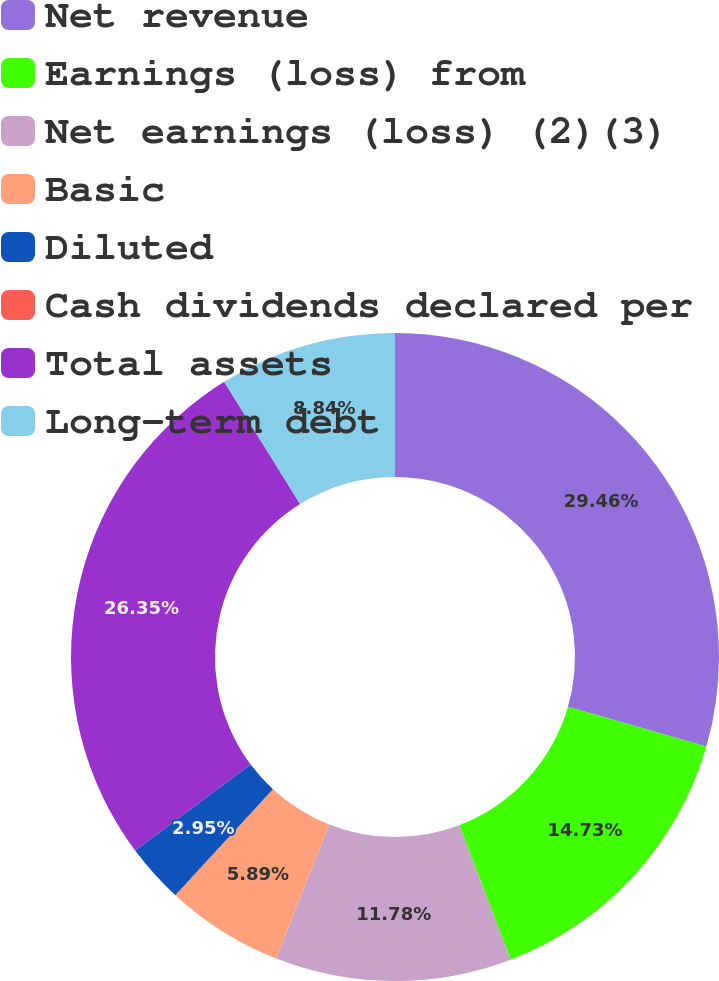<chart> <loc_0><loc_0><loc_500><loc_500><pie_chart><fcel>Net revenue<fcel>Earnings (loss) from<fcel>Net earnings (loss) (2)(3)<fcel>Basic<fcel>Diluted<fcel>Cash dividends declared per<fcel>Total assets<fcel>Long-term debt<nl><fcel>29.46%<fcel>14.73%<fcel>11.78%<fcel>5.89%<fcel>2.95%<fcel>0.0%<fcel>26.35%<fcel>8.84%<nl></chart> 